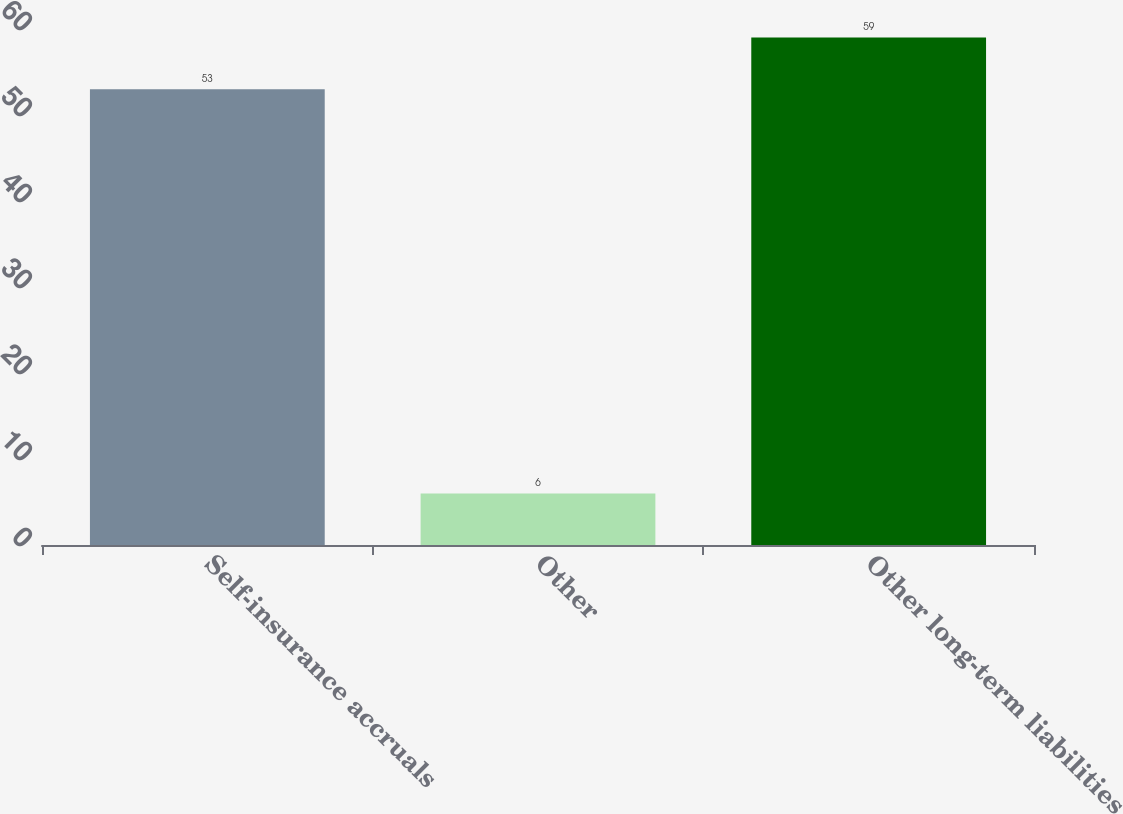Convert chart. <chart><loc_0><loc_0><loc_500><loc_500><bar_chart><fcel>Self-insurance accruals<fcel>Other<fcel>Other long-term liabilities<nl><fcel>53<fcel>6<fcel>59<nl></chart> 